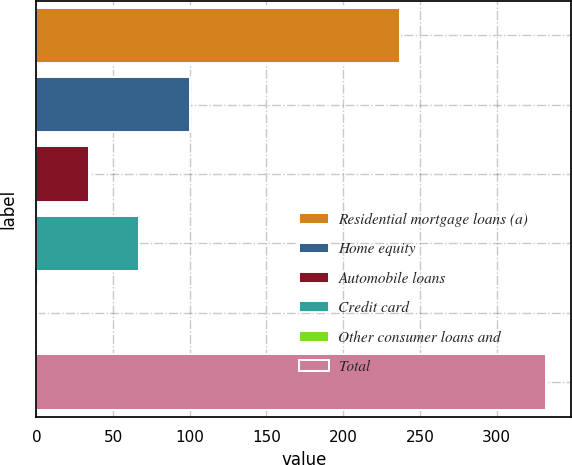Convert chart. <chart><loc_0><loc_0><loc_500><loc_500><bar_chart><fcel>Residential mortgage loans (a)<fcel>Home equity<fcel>Automobile loans<fcel>Credit card<fcel>Other consumer loans and<fcel>Total<nl><fcel>237<fcel>100.3<fcel>34.1<fcel>67.2<fcel>1<fcel>332<nl></chart> 